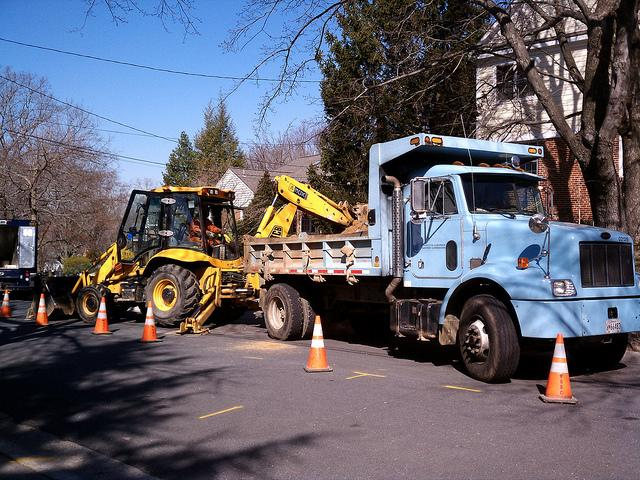What is near the blue truck? Please explain your reasoning. traffic cone. There are traffic cones near the truck. 